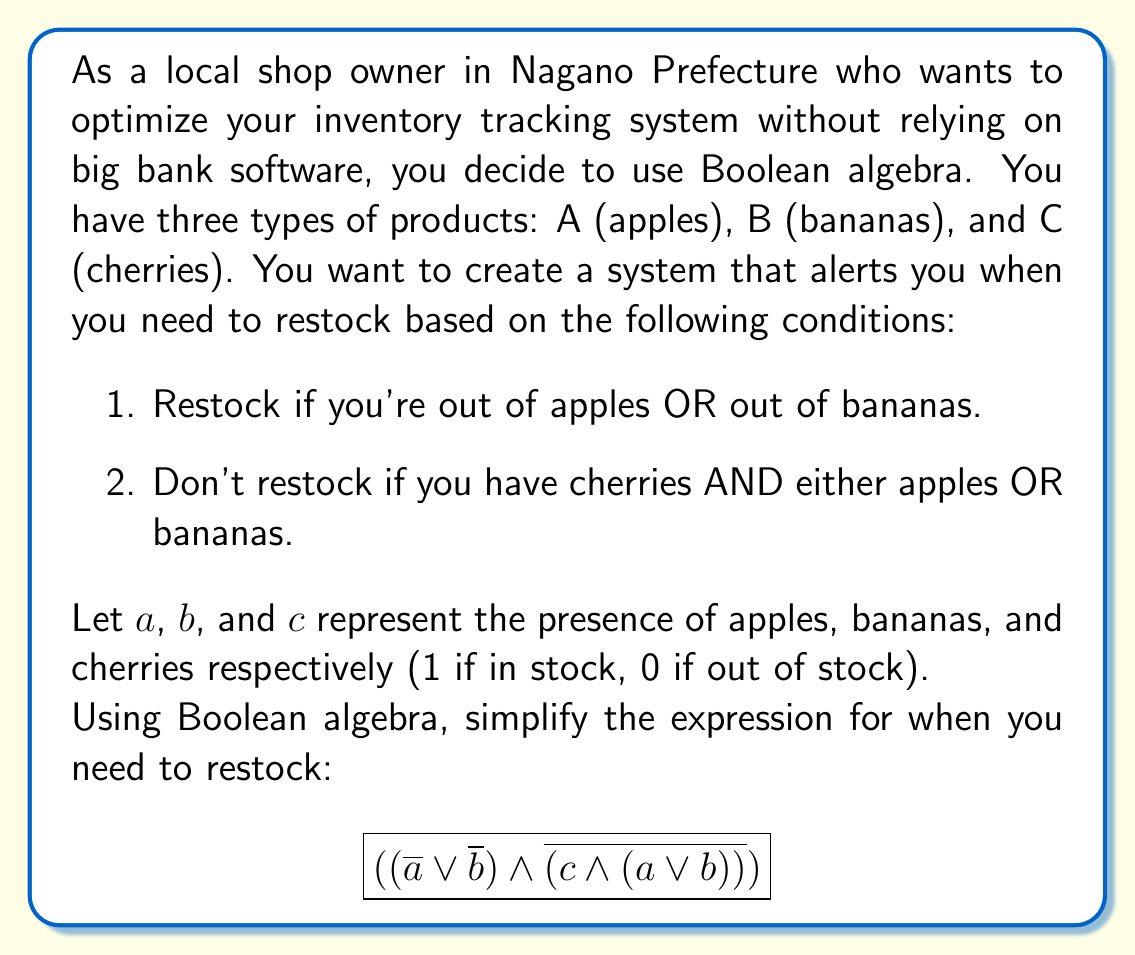Solve this math problem. Let's simplify this expression step by step:

1) Start with $$((\overline{a} \lor \overline{b}) \land \overline{(c \land (a \lor b))})$$

2) Apply De Morgan's law to the second part:
   $$(\overline{a} \lor \overline{b}) \land (\overline{c} \lor \overline{(a \lor b)})$$

3) Apply De Morgan's law again to $\overline{(a \lor b)}$:
   $$(\overline{a} \lor \overline{b}) \land (\overline{c} \lor (\overline{a} \land \overline{b}))$$

4) Use the distributive property:
   $$(\overline{a} \lor \overline{b}) \land \overline{c} \lor (\overline{a} \lor \overline{b}) \land (\overline{a} \land \overline{b})$$

5) Simplify $(\overline{a} \lor \overline{b}) \land (\overline{a} \land \overline{b})$:
   This reduces to $(\overline{a} \land \overline{b})$ because if both $a$ and $b$ are false, then $\overline{a} \lor \overline{b}$ is always true.

6) Our expression is now:
   $$(\overline{a} \lor \overline{b}) \land \overline{c} \lor (\overline{a} \land \overline{b})$$

7) Factor out $(\overline{a} \land \overline{b})$:
   $$(\overline{a} \land \overline{b}) \lor ((\overline{a} \lor \overline{b}) \land \overline{c})$$

This is the simplified Boolean expression for when you need to restock.
Answer: $$(\overline{a} \land \overline{b}) \lor ((\overline{a} \lor \overline{b}) \land \overline{c})$$ 